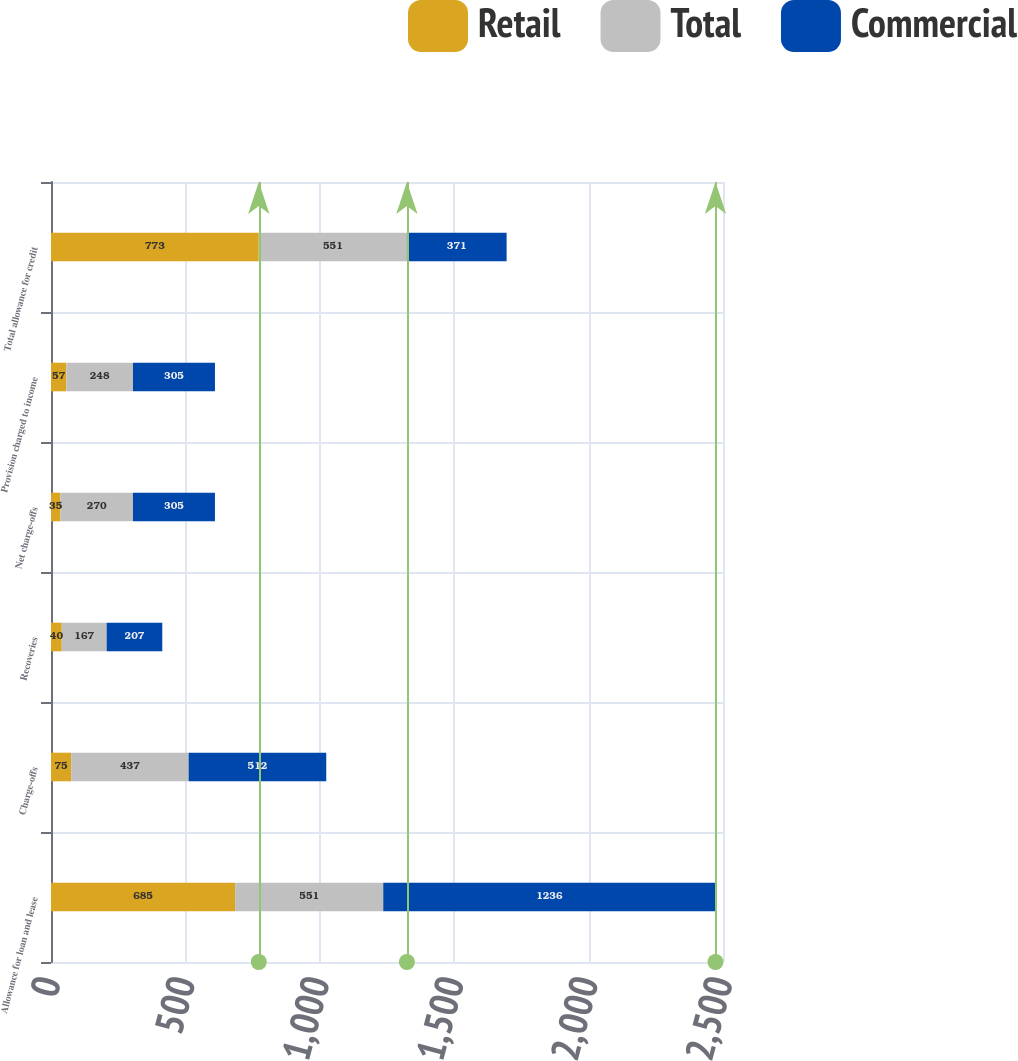<chart> <loc_0><loc_0><loc_500><loc_500><stacked_bar_chart><ecel><fcel>Allowance for loan and lease<fcel>Charge-offs<fcel>Recoveries<fcel>Net charge-offs<fcel>Provision charged to income<fcel>Total allowance for credit<nl><fcel>Retail<fcel>685<fcel>75<fcel>40<fcel>35<fcel>57<fcel>773<nl><fcel>Total<fcel>551<fcel>437<fcel>167<fcel>270<fcel>248<fcel>551<nl><fcel>Commercial<fcel>1236<fcel>512<fcel>207<fcel>305<fcel>305<fcel>371<nl></chart> 